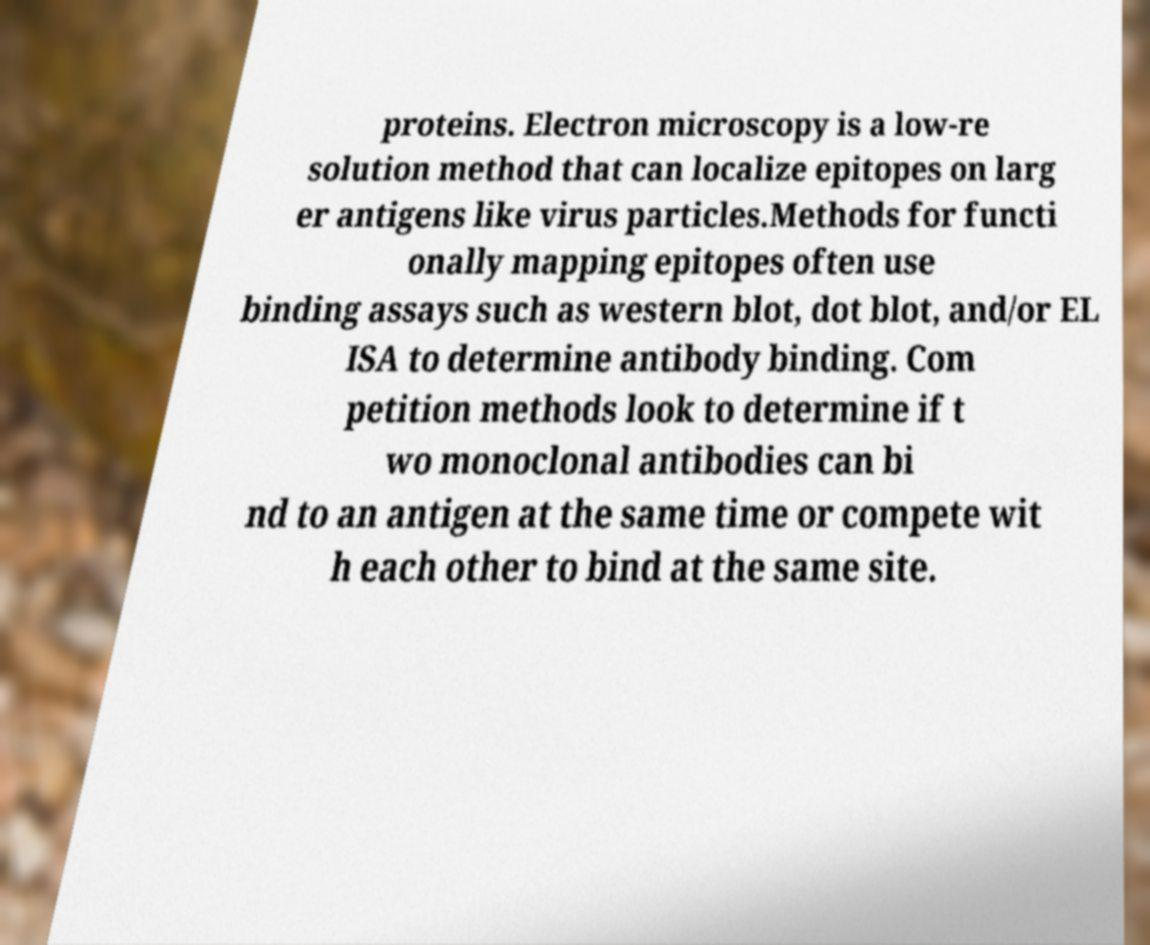Please read and relay the text visible in this image. What does it say? proteins. Electron microscopy is a low-re solution method that can localize epitopes on larg er antigens like virus particles.Methods for functi onally mapping epitopes often use binding assays such as western blot, dot blot, and/or EL ISA to determine antibody binding. Com petition methods look to determine if t wo monoclonal antibodies can bi nd to an antigen at the same time or compete wit h each other to bind at the same site. 